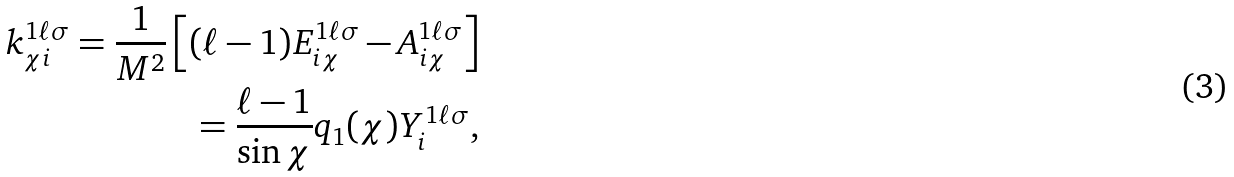Convert formula to latex. <formula><loc_0><loc_0><loc_500><loc_500>k _ { \chi i } ^ { 1 \ell \sigma } = \frac { 1 } { M ^ { 2 } } \left [ ( \ell - 1 ) E ^ { 1 \ell \sigma } _ { i \chi } - A ^ { 1 \ell \sigma } _ { i \chi } \right ] \\ = \frac { \ell - 1 } { \sin \chi } q _ { 1 } ( \chi ) Y _ { i } ^ { 1 \ell \sigma } ,</formula> 